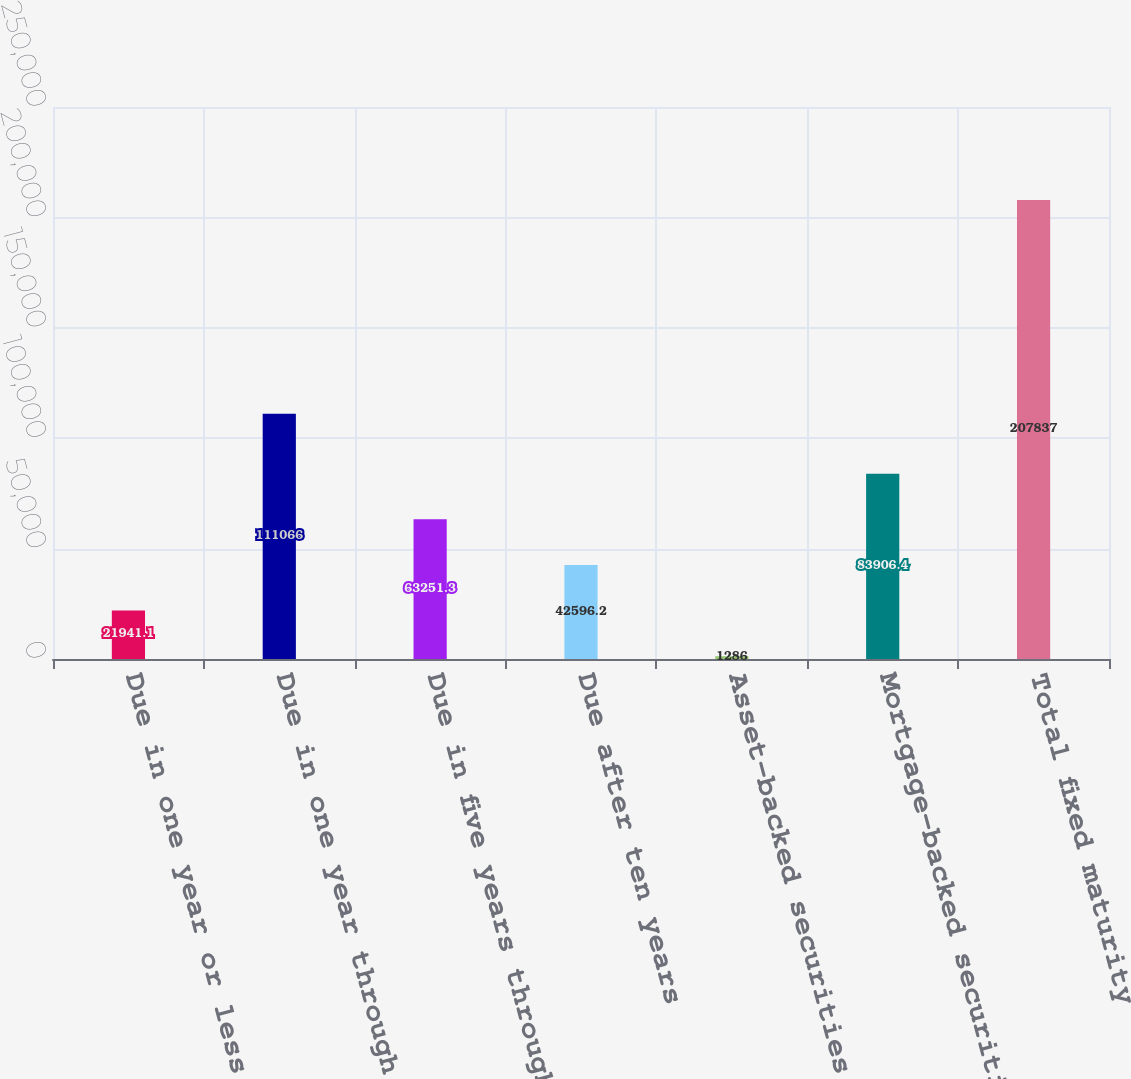Convert chart to OTSL. <chart><loc_0><loc_0><loc_500><loc_500><bar_chart><fcel>Due in one year or less<fcel>Due in one year through five<fcel>Due in five years through ten<fcel>Due after ten years<fcel>Asset-backed securities<fcel>Mortgage-backed securities<fcel>Total fixed maturity<nl><fcel>21941.1<fcel>111066<fcel>63251.3<fcel>42596.2<fcel>1286<fcel>83906.4<fcel>207837<nl></chart> 